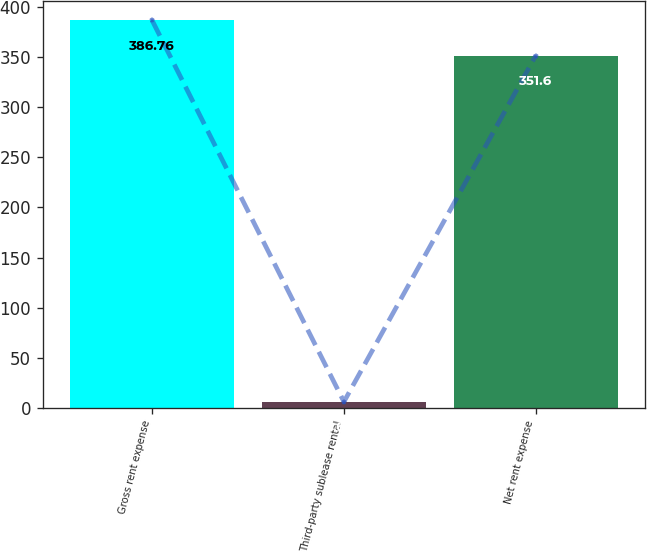Convert chart. <chart><loc_0><loc_0><loc_500><loc_500><bar_chart><fcel>Gross rent expense<fcel>Third-party sublease rental<fcel>Net rent expense<nl><fcel>386.76<fcel>6.1<fcel>351.6<nl></chart> 